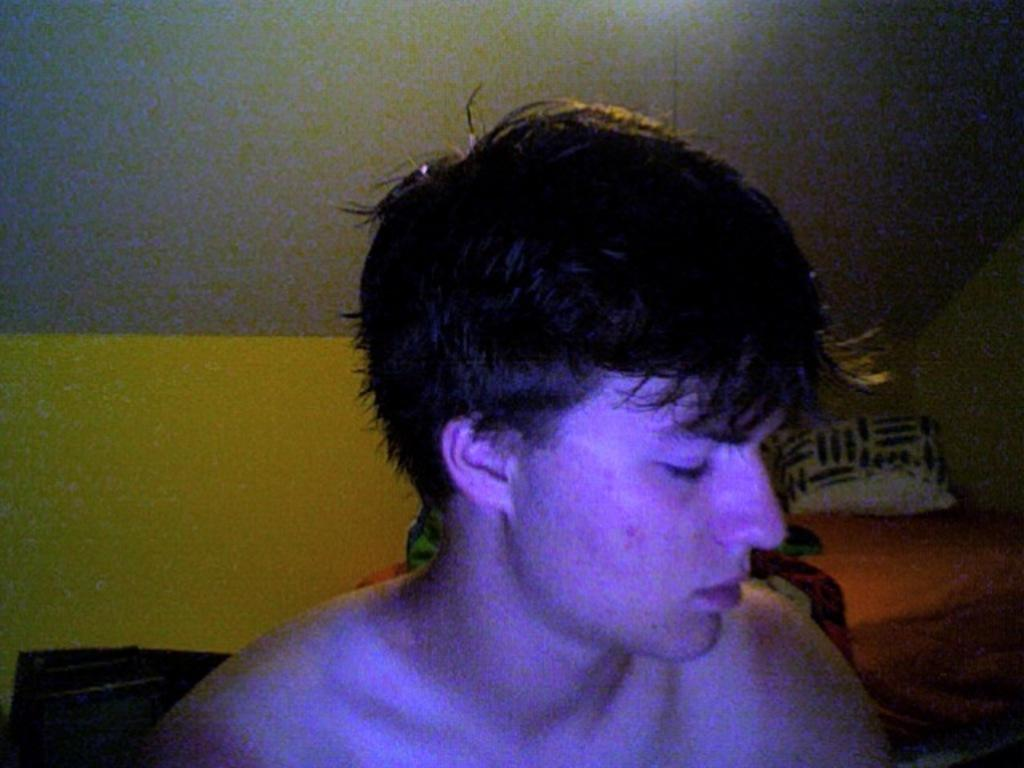Who is present in the image? There is a man in the image. What object can be seen on a bed in the image? There is a pillow on a bed in the image. What type of structure is visible in the image? There is a wall in the image. What is visible at the top of the image? The ceiling is visible at the top of the image. What type of plane is flying over the man in the image? There is no plane visible in the image; it only features a man, a pillow on a bed, a wall, and the ceiling. 